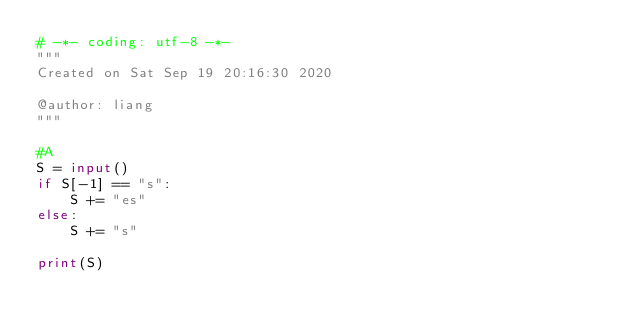<code> <loc_0><loc_0><loc_500><loc_500><_Python_># -*- coding: utf-8 -*-
"""
Created on Sat Sep 19 20:16:30 2020

@author: liang
"""
 
#A
S = input()
if S[-1] == "s":
    S += "es"
else:
    S += "s"

print(S)</code> 